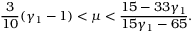<formula> <loc_0><loc_0><loc_500><loc_500>\frac { 3 } { 1 0 } ( \gamma _ { 1 } - 1 ) < \mu < \frac { 1 5 - 3 3 \gamma _ { 1 } } { 1 5 \gamma _ { 1 } - 6 5 } .</formula> 